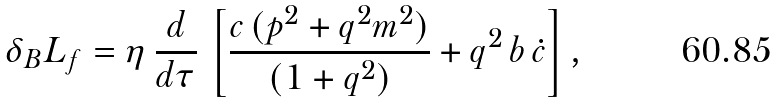<formula> <loc_0><loc_0><loc_500><loc_500>\delta _ { B } L _ { f } = \eta \, \frac { d } { d \tau } \, \left [ \frac { c \, ( p ^ { 2 } + q ^ { 2 } m ^ { 2 } ) } { ( 1 + q ^ { 2 } ) } + q ^ { 2 } \, b \, \dot { c } \right ] ,</formula> 